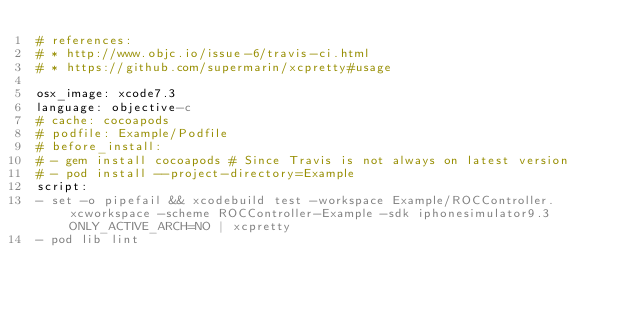Convert code to text. <code><loc_0><loc_0><loc_500><loc_500><_YAML_># references:
# * http://www.objc.io/issue-6/travis-ci.html
# * https://github.com/supermarin/xcpretty#usage

osx_image: xcode7.3
language: objective-c
# cache: cocoapods
# podfile: Example/Podfile
# before_install:
# - gem install cocoapods # Since Travis is not always on latest version
# - pod install --project-directory=Example
script:
- set -o pipefail && xcodebuild test -workspace Example/ROCController.xcworkspace -scheme ROCController-Example -sdk iphonesimulator9.3 ONLY_ACTIVE_ARCH=NO | xcpretty
- pod lib lint
</code> 